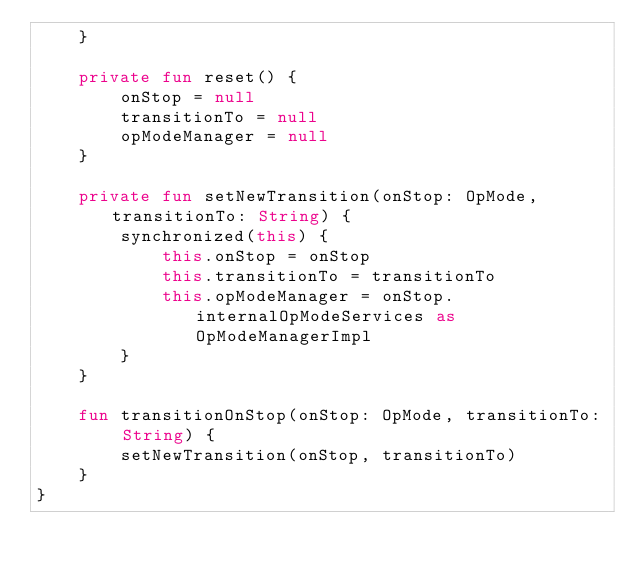Convert code to text. <code><loc_0><loc_0><loc_500><loc_500><_Kotlin_>    }

    private fun reset() {
        onStop = null
        transitionTo = null
        opModeManager = null
    }

    private fun setNewTransition(onStop: OpMode, transitionTo: String) {
        synchronized(this) {
            this.onStop = onStop
            this.transitionTo = transitionTo
            this.opModeManager = onStop.internalOpModeServices as OpModeManagerImpl
        }
    }

    fun transitionOnStop(onStop: OpMode, transitionTo: String) {
        setNewTransition(onStop, transitionTo)
    }
}</code> 